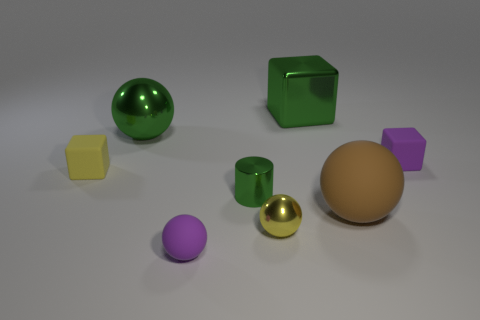What is the arrangement of the objects in terms of color brightness? The objects' colors vary in brightness, from the bright yellow cube on the left to the darker green cube. The golden sphere has a reflective property that makes it stand out, while the purple and brown objects have more subdued hues. 